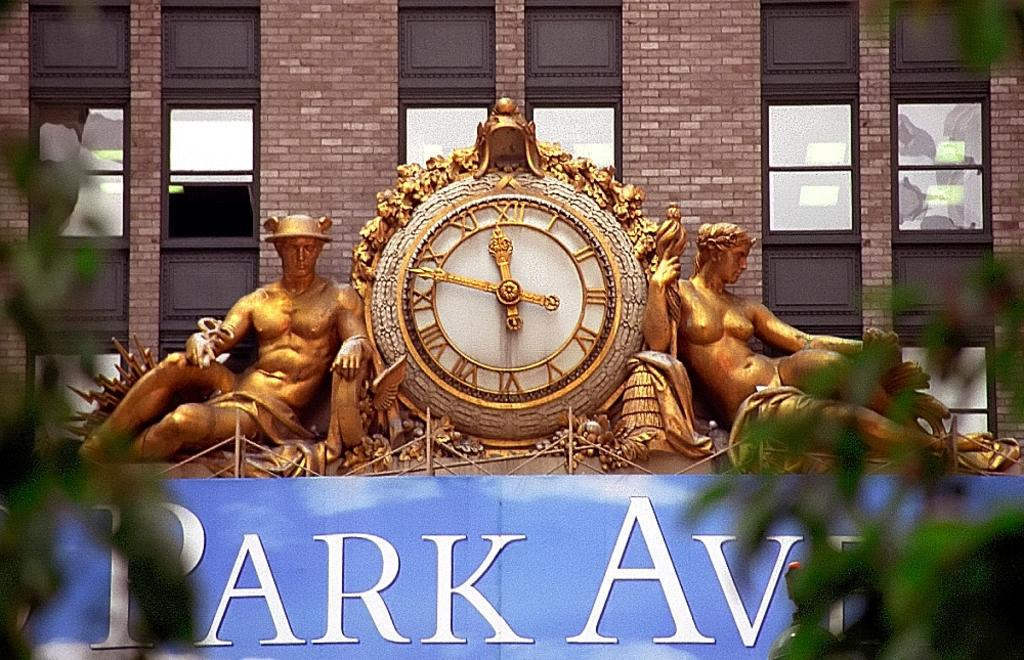Provide a one-sentence caption for the provided image. Small clock above a sign that says PARK AVE. 